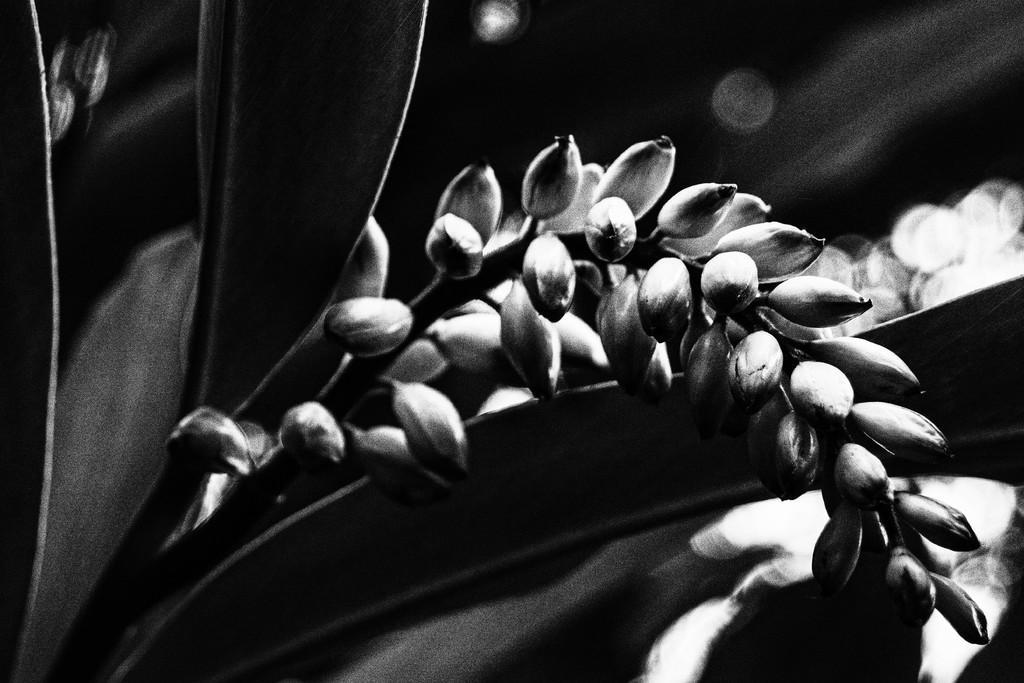Could you give a brief overview of what you see in this image? In this black and white picture we can see some kind of flowers and leaves , and the background is black. 